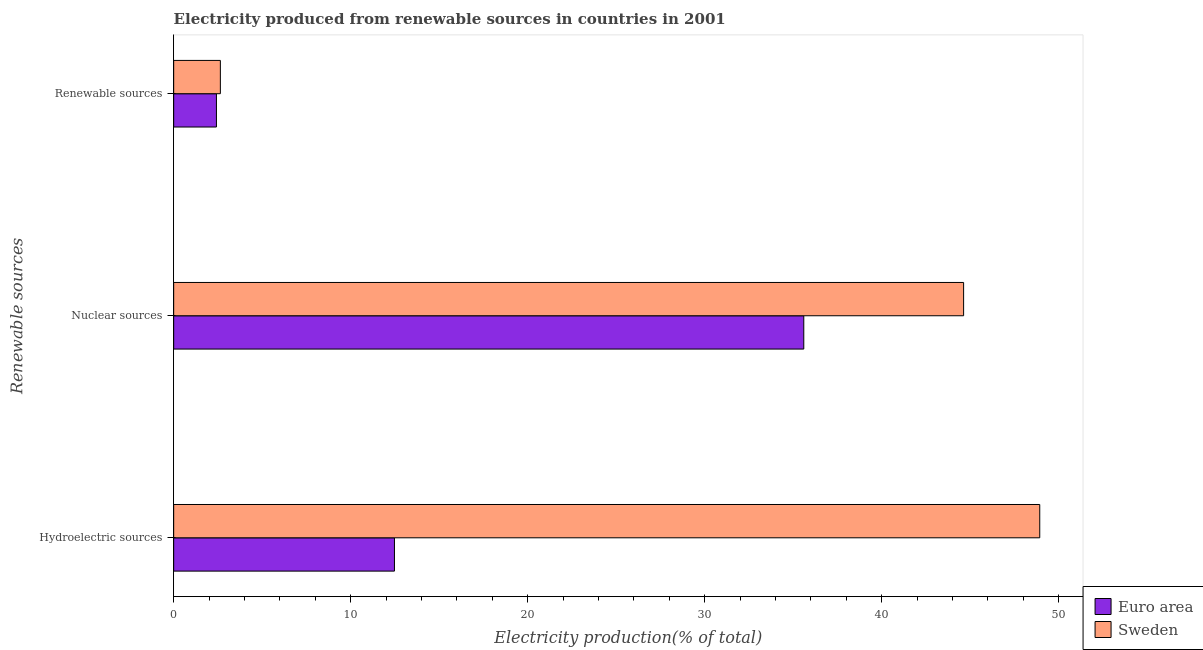How many different coloured bars are there?
Your answer should be compact. 2. Are the number of bars per tick equal to the number of legend labels?
Provide a succinct answer. Yes. Are the number of bars on each tick of the Y-axis equal?
Your answer should be very brief. Yes. How many bars are there on the 2nd tick from the top?
Provide a succinct answer. 2. How many bars are there on the 3rd tick from the bottom?
Keep it short and to the point. 2. What is the label of the 2nd group of bars from the top?
Your answer should be compact. Nuclear sources. What is the percentage of electricity produced by nuclear sources in Sweden?
Your answer should be very brief. 44.62. Across all countries, what is the maximum percentage of electricity produced by hydroelectric sources?
Provide a succinct answer. 48.92. Across all countries, what is the minimum percentage of electricity produced by nuclear sources?
Provide a succinct answer. 35.59. What is the total percentage of electricity produced by hydroelectric sources in the graph?
Give a very brief answer. 61.4. What is the difference between the percentage of electricity produced by hydroelectric sources in Euro area and that in Sweden?
Give a very brief answer. -36.45. What is the difference between the percentage of electricity produced by hydroelectric sources in Sweden and the percentage of electricity produced by nuclear sources in Euro area?
Your answer should be very brief. 13.33. What is the average percentage of electricity produced by hydroelectric sources per country?
Provide a short and direct response. 30.7. What is the difference between the percentage of electricity produced by renewable sources and percentage of electricity produced by nuclear sources in Sweden?
Give a very brief answer. -41.99. In how many countries, is the percentage of electricity produced by nuclear sources greater than 46 %?
Keep it short and to the point. 0. What is the ratio of the percentage of electricity produced by renewable sources in Sweden to that in Euro area?
Make the answer very short. 1.09. Is the percentage of electricity produced by nuclear sources in Euro area less than that in Sweden?
Your answer should be compact. Yes. Is the difference between the percentage of electricity produced by renewable sources in Sweden and Euro area greater than the difference between the percentage of electricity produced by nuclear sources in Sweden and Euro area?
Keep it short and to the point. No. What is the difference between the highest and the second highest percentage of electricity produced by renewable sources?
Provide a succinct answer. 0.22. What is the difference between the highest and the lowest percentage of electricity produced by hydroelectric sources?
Ensure brevity in your answer.  36.45. Is the sum of the percentage of electricity produced by renewable sources in Sweden and Euro area greater than the maximum percentage of electricity produced by hydroelectric sources across all countries?
Ensure brevity in your answer.  No. What does the 2nd bar from the top in Nuclear sources represents?
Make the answer very short. Euro area. How many bars are there?
Ensure brevity in your answer.  6. Are all the bars in the graph horizontal?
Provide a short and direct response. Yes. Does the graph contain grids?
Keep it short and to the point. No. What is the title of the graph?
Keep it short and to the point. Electricity produced from renewable sources in countries in 2001. What is the label or title of the X-axis?
Keep it short and to the point. Electricity production(% of total). What is the label or title of the Y-axis?
Make the answer very short. Renewable sources. What is the Electricity production(% of total) in Euro area in Hydroelectric sources?
Ensure brevity in your answer.  12.47. What is the Electricity production(% of total) of Sweden in Hydroelectric sources?
Ensure brevity in your answer.  48.92. What is the Electricity production(% of total) of Euro area in Nuclear sources?
Offer a very short reply. 35.59. What is the Electricity production(% of total) in Sweden in Nuclear sources?
Give a very brief answer. 44.62. What is the Electricity production(% of total) in Euro area in Renewable sources?
Your answer should be very brief. 2.42. What is the Electricity production(% of total) of Sweden in Renewable sources?
Ensure brevity in your answer.  2.64. Across all Renewable sources, what is the maximum Electricity production(% of total) in Euro area?
Provide a succinct answer. 35.59. Across all Renewable sources, what is the maximum Electricity production(% of total) of Sweden?
Your answer should be compact. 48.92. Across all Renewable sources, what is the minimum Electricity production(% of total) of Euro area?
Your answer should be compact. 2.42. Across all Renewable sources, what is the minimum Electricity production(% of total) of Sweden?
Ensure brevity in your answer.  2.64. What is the total Electricity production(% of total) of Euro area in the graph?
Offer a very short reply. 50.48. What is the total Electricity production(% of total) in Sweden in the graph?
Your answer should be compact. 96.18. What is the difference between the Electricity production(% of total) in Euro area in Hydroelectric sources and that in Nuclear sources?
Your answer should be very brief. -23.12. What is the difference between the Electricity production(% of total) of Sweden in Hydroelectric sources and that in Nuclear sources?
Ensure brevity in your answer.  4.3. What is the difference between the Electricity production(% of total) in Euro area in Hydroelectric sources and that in Renewable sources?
Ensure brevity in your answer.  10.06. What is the difference between the Electricity production(% of total) in Sweden in Hydroelectric sources and that in Renewable sources?
Offer a very short reply. 46.29. What is the difference between the Electricity production(% of total) of Euro area in Nuclear sources and that in Renewable sources?
Your answer should be very brief. 33.18. What is the difference between the Electricity production(% of total) of Sweden in Nuclear sources and that in Renewable sources?
Offer a terse response. 41.99. What is the difference between the Electricity production(% of total) in Euro area in Hydroelectric sources and the Electricity production(% of total) in Sweden in Nuclear sources?
Offer a very short reply. -32.15. What is the difference between the Electricity production(% of total) of Euro area in Hydroelectric sources and the Electricity production(% of total) of Sweden in Renewable sources?
Offer a very short reply. 9.84. What is the difference between the Electricity production(% of total) of Euro area in Nuclear sources and the Electricity production(% of total) of Sweden in Renewable sources?
Offer a very short reply. 32.96. What is the average Electricity production(% of total) in Euro area per Renewable sources?
Offer a very short reply. 16.83. What is the average Electricity production(% of total) of Sweden per Renewable sources?
Keep it short and to the point. 32.06. What is the difference between the Electricity production(% of total) in Euro area and Electricity production(% of total) in Sweden in Hydroelectric sources?
Provide a short and direct response. -36.45. What is the difference between the Electricity production(% of total) in Euro area and Electricity production(% of total) in Sweden in Nuclear sources?
Give a very brief answer. -9.03. What is the difference between the Electricity production(% of total) of Euro area and Electricity production(% of total) of Sweden in Renewable sources?
Provide a succinct answer. -0.22. What is the ratio of the Electricity production(% of total) in Euro area in Hydroelectric sources to that in Nuclear sources?
Provide a succinct answer. 0.35. What is the ratio of the Electricity production(% of total) in Sweden in Hydroelectric sources to that in Nuclear sources?
Offer a terse response. 1.1. What is the ratio of the Electricity production(% of total) in Euro area in Hydroelectric sources to that in Renewable sources?
Keep it short and to the point. 5.16. What is the ratio of the Electricity production(% of total) of Sweden in Hydroelectric sources to that in Renewable sources?
Your response must be concise. 18.55. What is the ratio of the Electricity production(% of total) in Euro area in Nuclear sources to that in Renewable sources?
Offer a very short reply. 14.73. What is the ratio of the Electricity production(% of total) in Sweden in Nuclear sources to that in Renewable sources?
Your answer should be compact. 16.92. What is the difference between the highest and the second highest Electricity production(% of total) of Euro area?
Your response must be concise. 23.12. What is the difference between the highest and the second highest Electricity production(% of total) in Sweden?
Make the answer very short. 4.3. What is the difference between the highest and the lowest Electricity production(% of total) in Euro area?
Keep it short and to the point. 33.18. What is the difference between the highest and the lowest Electricity production(% of total) in Sweden?
Give a very brief answer. 46.29. 